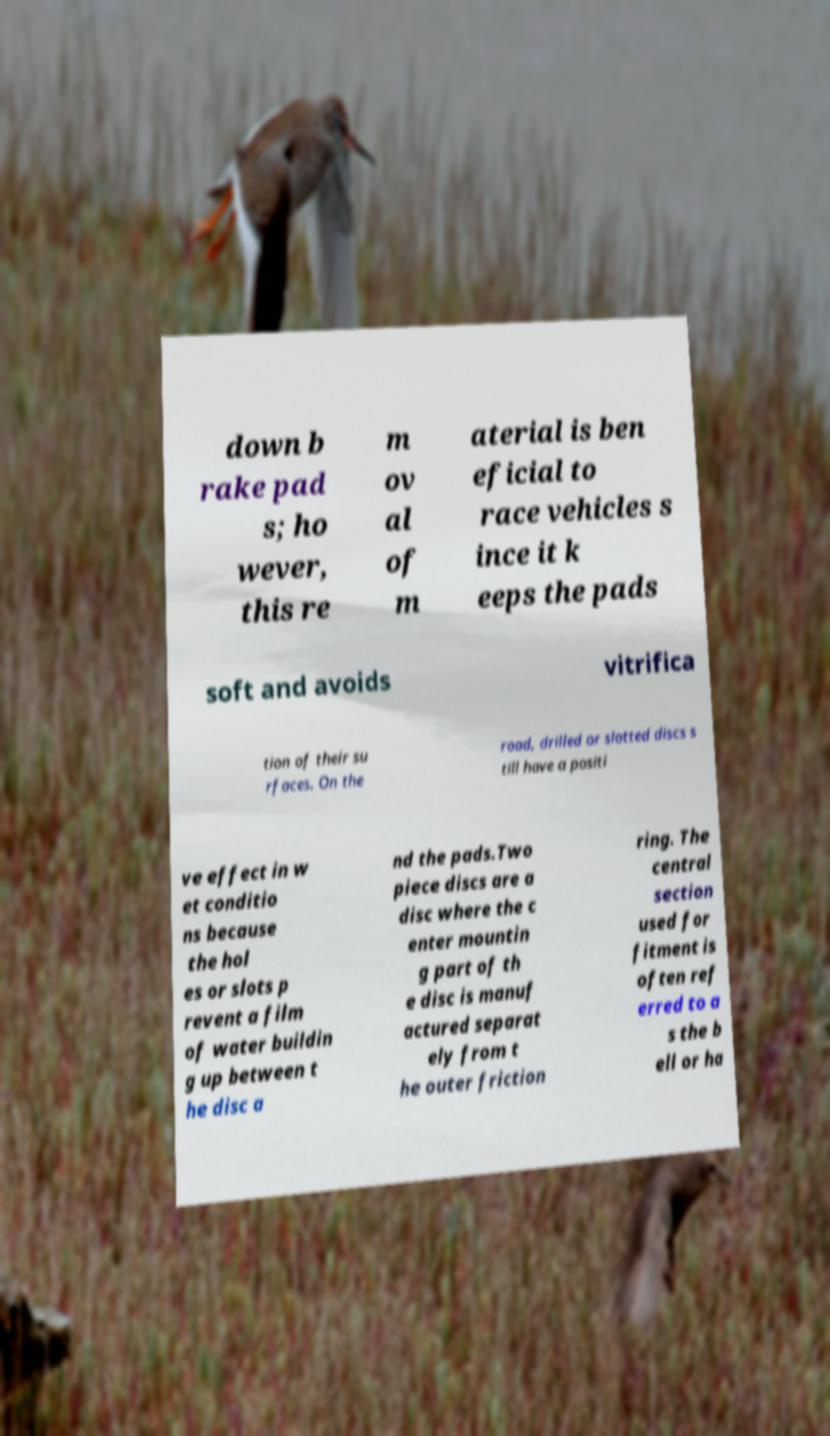I need the written content from this picture converted into text. Can you do that? down b rake pad s; ho wever, this re m ov al of m aterial is ben eficial to race vehicles s ince it k eeps the pads soft and avoids vitrifica tion of their su rfaces. On the road, drilled or slotted discs s till have a positi ve effect in w et conditio ns because the hol es or slots p revent a film of water buildin g up between t he disc a nd the pads.Two piece discs are a disc where the c enter mountin g part of th e disc is manuf actured separat ely from t he outer friction ring. The central section used for fitment is often ref erred to a s the b ell or ha 